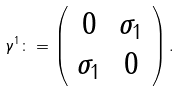<formula> <loc_0><loc_0><loc_500><loc_500>\gamma ^ { 1 } \colon = \left ( \begin{array} { * { 2 } { c } } 0 & \sigma _ { 1 } \\ \sigma _ { 1 } & 0 \end{array} \right ) .</formula> 